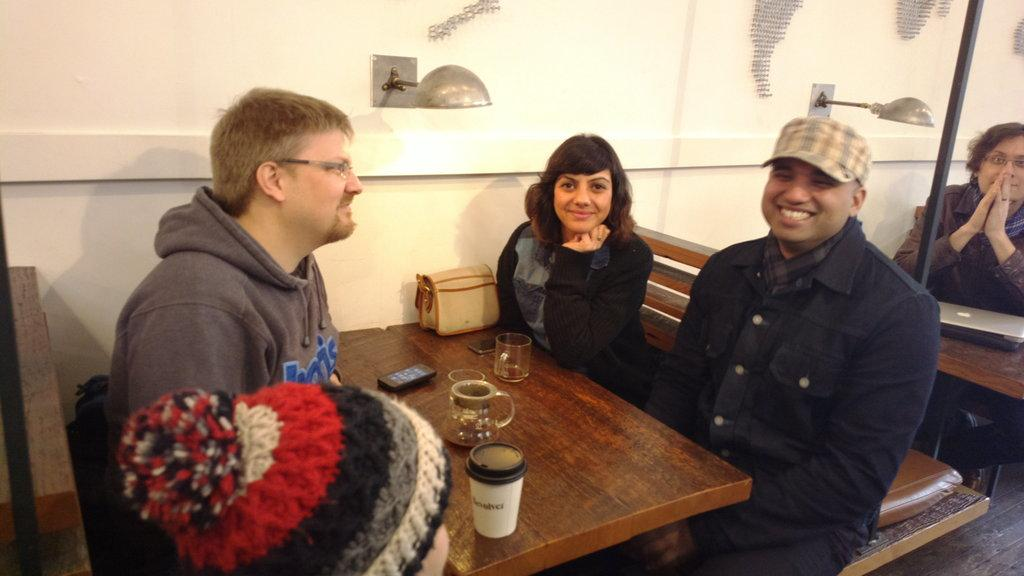What are the people in the image doing? The people in the image are sitting on a bench and smiling. What can be seen in the image besides the people on the bench? There are tables in the image, and items are placed on the tables. What is the color of the wall in the background of the image? The wall in the background of the image is white-colored. What is visible in the background of the image? There are lights visible in the background. How many berries are on the table in the image? There is no mention of berries in the image, so we cannot determine the amount. 